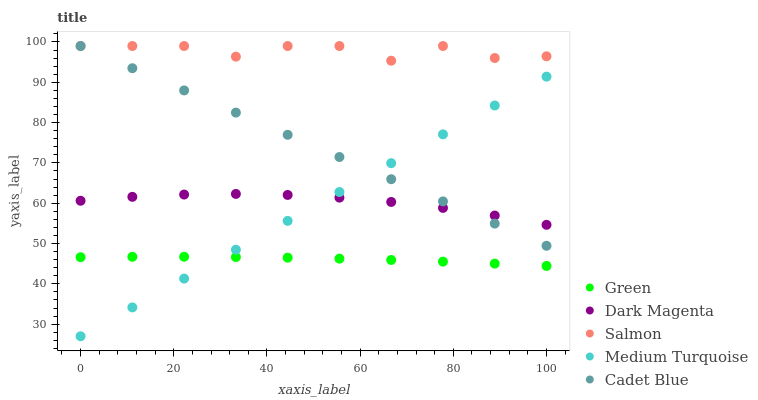Does Green have the minimum area under the curve?
Answer yes or no. Yes. Does Salmon have the maximum area under the curve?
Answer yes or no. Yes. Does Cadet Blue have the minimum area under the curve?
Answer yes or no. No. Does Cadet Blue have the maximum area under the curve?
Answer yes or no. No. Is Cadet Blue the smoothest?
Answer yes or no. Yes. Is Salmon the roughest?
Answer yes or no. Yes. Is Green the smoothest?
Answer yes or no. No. Is Green the roughest?
Answer yes or no. No. Does Medium Turquoise have the lowest value?
Answer yes or no. Yes. Does Cadet Blue have the lowest value?
Answer yes or no. No. Does Cadet Blue have the highest value?
Answer yes or no. Yes. Does Green have the highest value?
Answer yes or no. No. Is Green less than Salmon?
Answer yes or no. Yes. Is Salmon greater than Medium Turquoise?
Answer yes or no. Yes. Does Medium Turquoise intersect Cadet Blue?
Answer yes or no. Yes. Is Medium Turquoise less than Cadet Blue?
Answer yes or no. No. Is Medium Turquoise greater than Cadet Blue?
Answer yes or no. No. Does Green intersect Salmon?
Answer yes or no. No. 